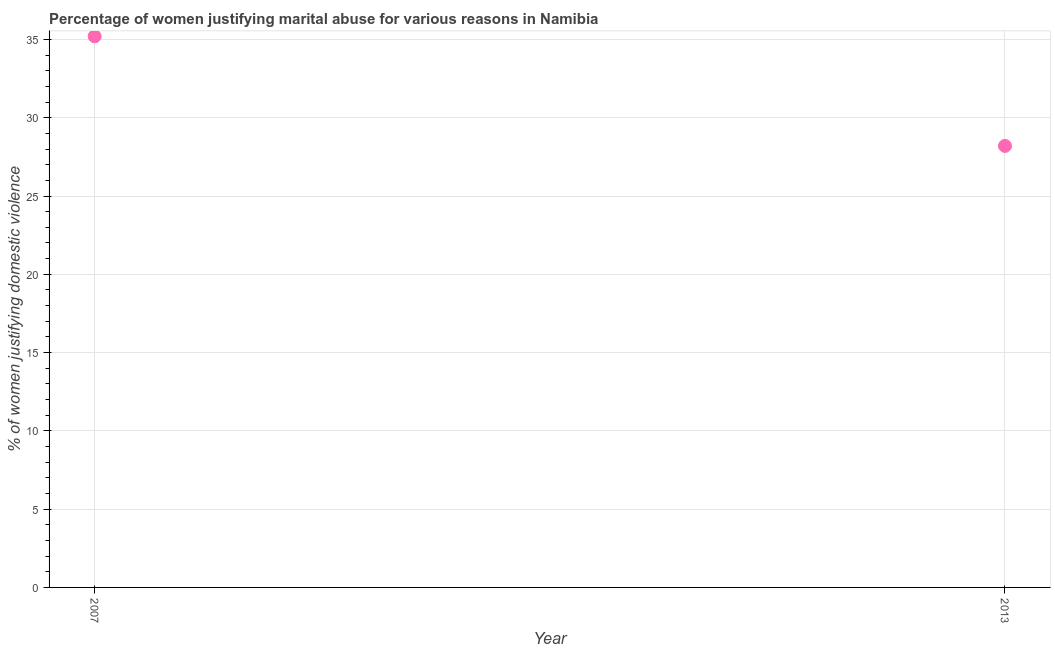What is the percentage of women justifying marital abuse in 2013?
Your answer should be compact. 28.2. Across all years, what is the maximum percentage of women justifying marital abuse?
Offer a very short reply. 35.2. Across all years, what is the minimum percentage of women justifying marital abuse?
Your answer should be compact. 28.2. In which year was the percentage of women justifying marital abuse maximum?
Give a very brief answer. 2007. In which year was the percentage of women justifying marital abuse minimum?
Offer a very short reply. 2013. What is the sum of the percentage of women justifying marital abuse?
Ensure brevity in your answer.  63.4. What is the difference between the percentage of women justifying marital abuse in 2007 and 2013?
Provide a succinct answer. 7. What is the average percentage of women justifying marital abuse per year?
Give a very brief answer. 31.7. What is the median percentage of women justifying marital abuse?
Offer a very short reply. 31.7. In how many years, is the percentage of women justifying marital abuse greater than 14 %?
Your answer should be compact. 2. What is the ratio of the percentage of women justifying marital abuse in 2007 to that in 2013?
Your response must be concise. 1.25. Does the percentage of women justifying marital abuse monotonically increase over the years?
Ensure brevity in your answer.  No. How many dotlines are there?
Your response must be concise. 1. What is the difference between two consecutive major ticks on the Y-axis?
Your answer should be compact. 5. Are the values on the major ticks of Y-axis written in scientific E-notation?
Your answer should be very brief. No. Does the graph contain any zero values?
Provide a succinct answer. No. Does the graph contain grids?
Your answer should be compact. Yes. What is the title of the graph?
Your answer should be compact. Percentage of women justifying marital abuse for various reasons in Namibia. What is the label or title of the Y-axis?
Ensure brevity in your answer.  % of women justifying domestic violence. What is the % of women justifying domestic violence in 2007?
Provide a short and direct response. 35.2. What is the % of women justifying domestic violence in 2013?
Your answer should be compact. 28.2. What is the difference between the % of women justifying domestic violence in 2007 and 2013?
Your answer should be compact. 7. What is the ratio of the % of women justifying domestic violence in 2007 to that in 2013?
Provide a succinct answer. 1.25. 